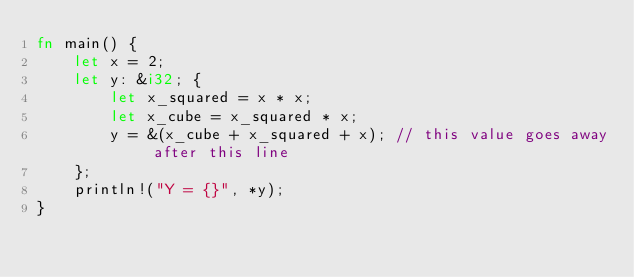<code> <loc_0><loc_0><loc_500><loc_500><_Rust_>fn main() {
    let x = 2;
    let y: &i32; {
        let x_squared = x * x;
        let x_cube = x_squared * x;
        y = &(x_cube + x_squared + x); // this value goes away after this line
    };
    println!("Y = {}", *y);
}
</code> 